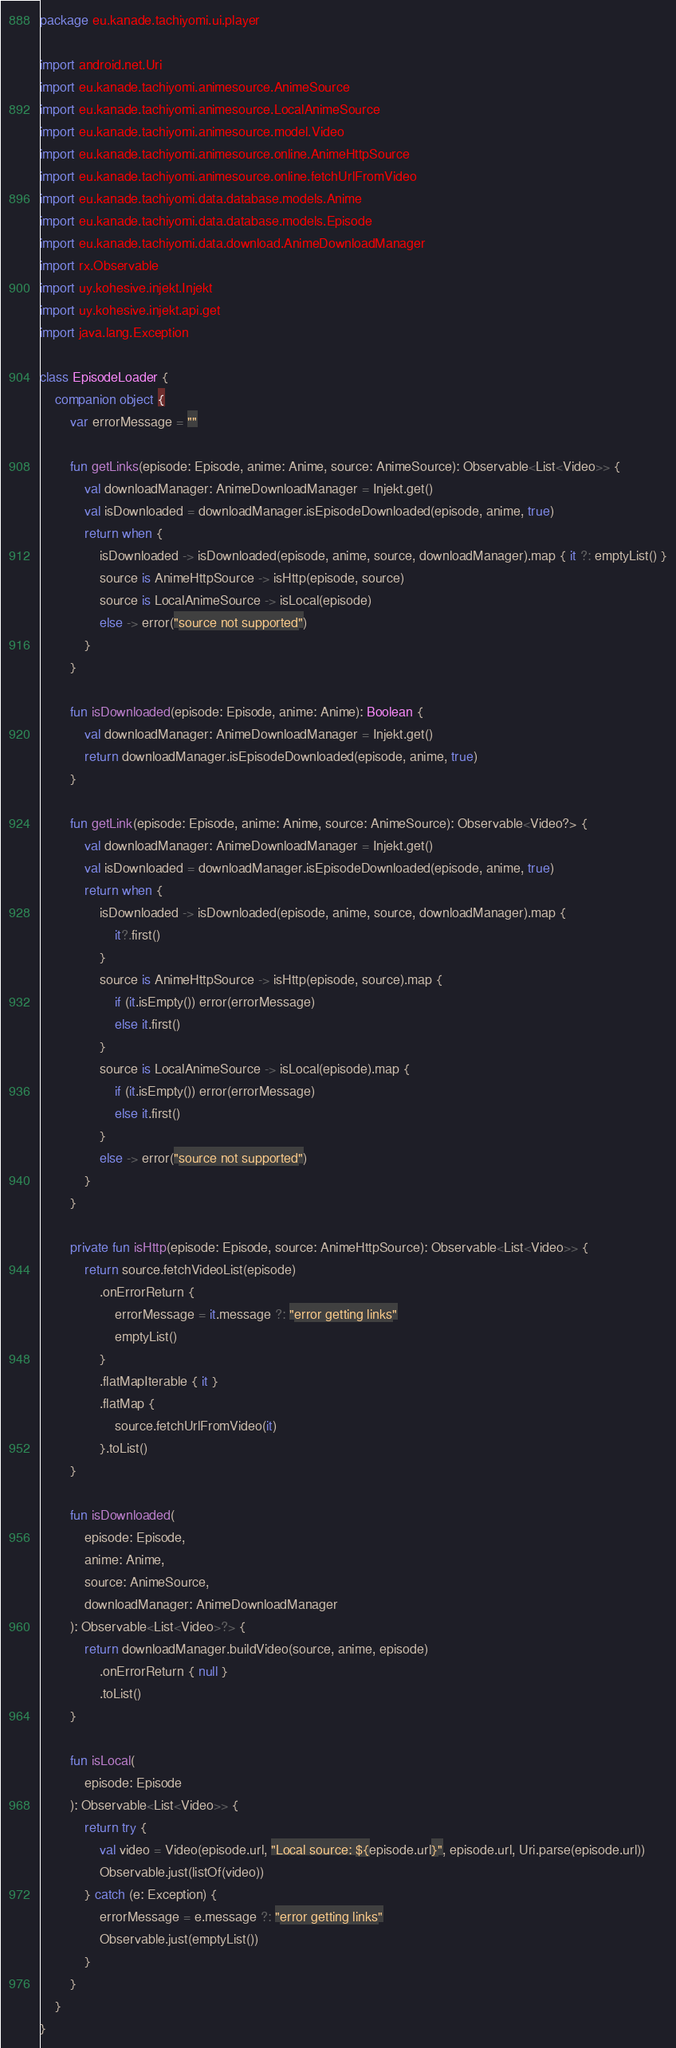Convert code to text. <code><loc_0><loc_0><loc_500><loc_500><_Kotlin_>package eu.kanade.tachiyomi.ui.player

import android.net.Uri
import eu.kanade.tachiyomi.animesource.AnimeSource
import eu.kanade.tachiyomi.animesource.LocalAnimeSource
import eu.kanade.tachiyomi.animesource.model.Video
import eu.kanade.tachiyomi.animesource.online.AnimeHttpSource
import eu.kanade.tachiyomi.animesource.online.fetchUrlFromVideo
import eu.kanade.tachiyomi.data.database.models.Anime
import eu.kanade.tachiyomi.data.database.models.Episode
import eu.kanade.tachiyomi.data.download.AnimeDownloadManager
import rx.Observable
import uy.kohesive.injekt.Injekt
import uy.kohesive.injekt.api.get
import java.lang.Exception

class EpisodeLoader {
    companion object {
        var errorMessage = ""

        fun getLinks(episode: Episode, anime: Anime, source: AnimeSource): Observable<List<Video>> {
            val downloadManager: AnimeDownloadManager = Injekt.get()
            val isDownloaded = downloadManager.isEpisodeDownloaded(episode, anime, true)
            return when {
                isDownloaded -> isDownloaded(episode, anime, source, downloadManager).map { it ?: emptyList() }
                source is AnimeHttpSource -> isHttp(episode, source)
                source is LocalAnimeSource -> isLocal(episode)
                else -> error("source not supported")
            }
        }

        fun isDownloaded(episode: Episode, anime: Anime): Boolean {
            val downloadManager: AnimeDownloadManager = Injekt.get()
            return downloadManager.isEpisodeDownloaded(episode, anime, true)
        }

        fun getLink(episode: Episode, anime: Anime, source: AnimeSource): Observable<Video?> {
            val downloadManager: AnimeDownloadManager = Injekt.get()
            val isDownloaded = downloadManager.isEpisodeDownloaded(episode, anime, true)
            return when {
                isDownloaded -> isDownloaded(episode, anime, source, downloadManager).map {
                    it?.first()
                }
                source is AnimeHttpSource -> isHttp(episode, source).map {
                    if (it.isEmpty()) error(errorMessage)
                    else it.first()
                }
                source is LocalAnimeSource -> isLocal(episode).map {
                    if (it.isEmpty()) error(errorMessage)
                    else it.first()
                }
                else -> error("source not supported")
            }
        }

        private fun isHttp(episode: Episode, source: AnimeHttpSource): Observable<List<Video>> {
            return source.fetchVideoList(episode)
                .onErrorReturn {
                    errorMessage = it.message ?: "error getting links"
                    emptyList()
                }
                .flatMapIterable { it }
                .flatMap {
                    source.fetchUrlFromVideo(it)
                }.toList()
        }

        fun isDownloaded(
            episode: Episode,
            anime: Anime,
            source: AnimeSource,
            downloadManager: AnimeDownloadManager
        ): Observable<List<Video>?> {
            return downloadManager.buildVideo(source, anime, episode)
                .onErrorReturn { null }
                .toList()
        }

        fun isLocal(
            episode: Episode
        ): Observable<List<Video>> {
            return try {
                val video = Video(episode.url, "Local source: ${episode.url}", episode.url, Uri.parse(episode.url))
                Observable.just(listOf(video))
            } catch (e: Exception) {
                errorMessage = e.message ?: "error getting links"
                Observable.just(emptyList())
            }
        }
    }
}
</code> 